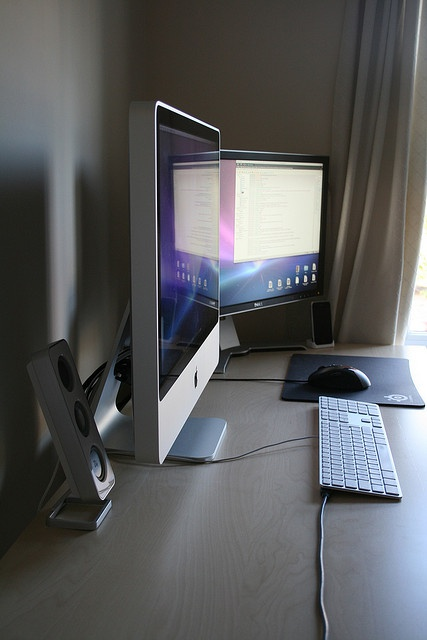Describe the objects in this image and their specific colors. I can see tv in gray, black, lightgray, and darkgray tones, tv in gray, ivory, black, and darkgray tones, keyboard in gray, lightblue, and darkgray tones, and mouse in gray and black tones in this image. 